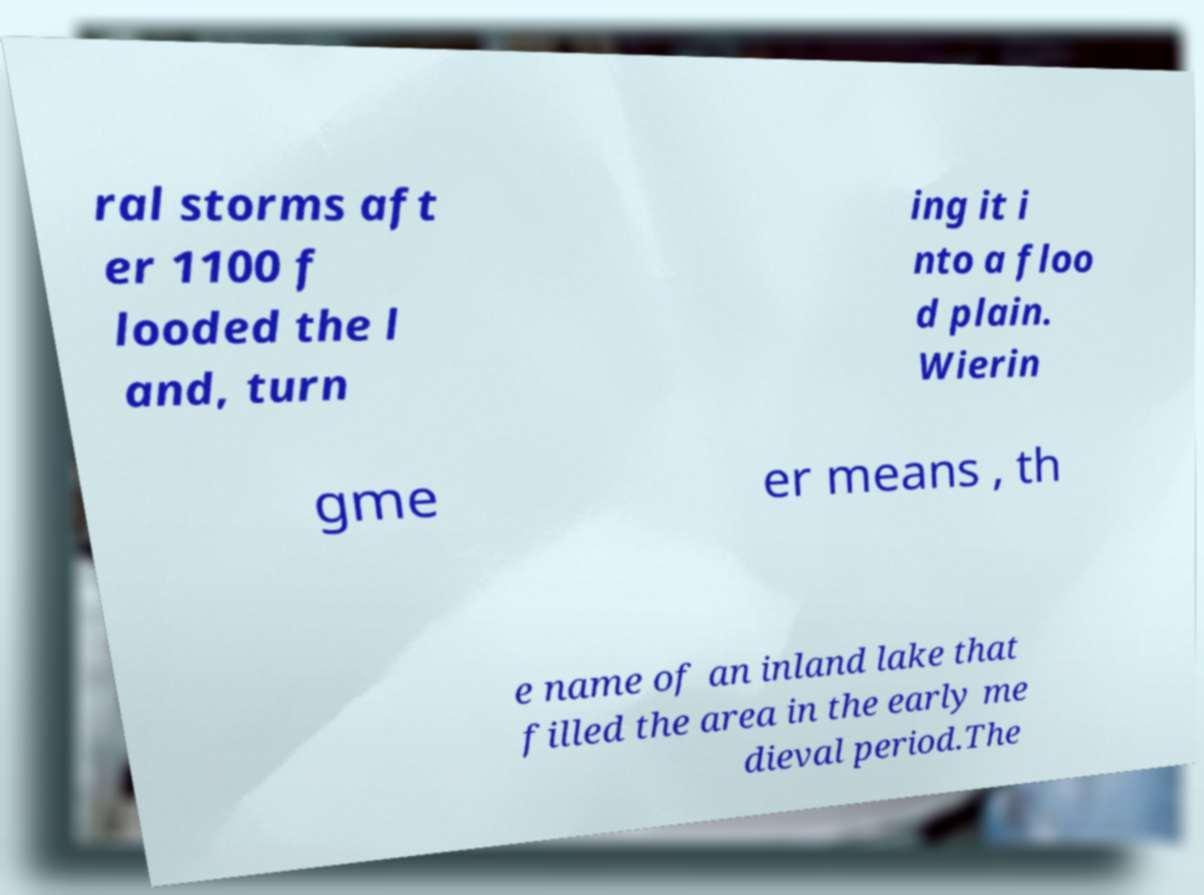Please read and relay the text visible in this image. What does it say? ral storms aft er 1100 f looded the l and, turn ing it i nto a floo d plain. Wierin gme er means , th e name of an inland lake that filled the area in the early me dieval period.The 